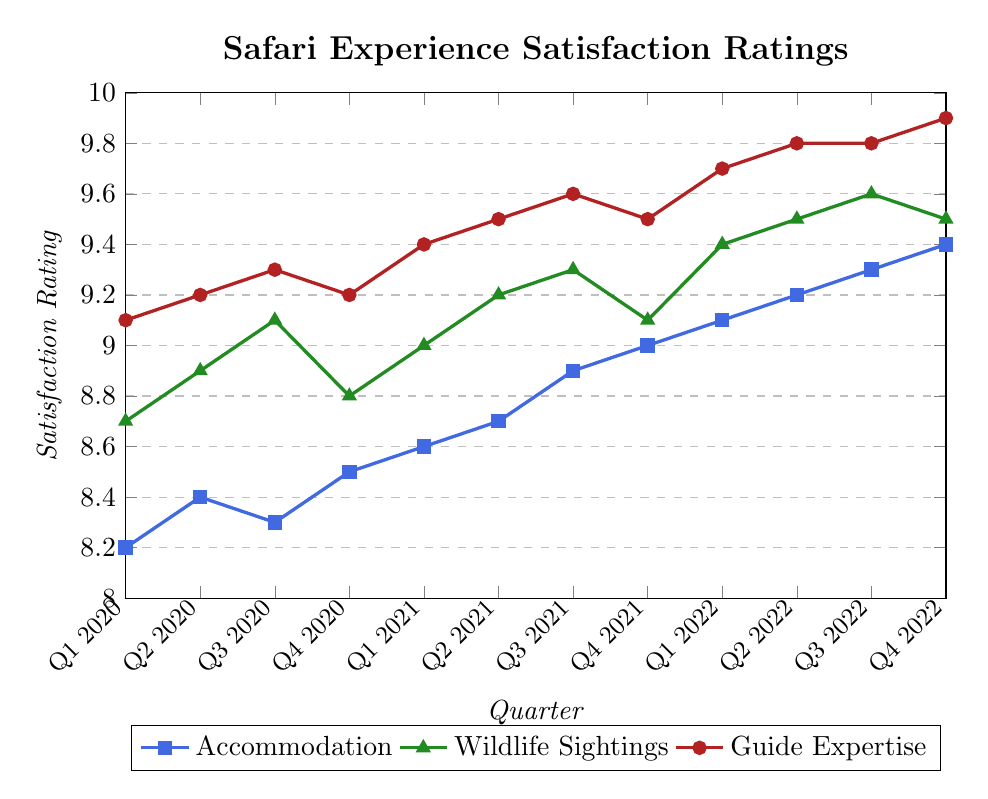What is the highest satisfaction rating for Guide Expertise and when did it occur? To determine the highest satisfaction rating for Guide Expertise, look at the red line representing Guide Expertise and find the peak value. This occurs at Q4 2022 with a value of 9.9.
Answer: 9.9, Q4 2022 Between Q1 2020 and Q4 2022, which aspect shows the most significant increase in satisfaction? Calculate the differences between Q1 2020 and Q4 2022 for each aspect. Accommodation increased from 8.2 to 9.4 by 1.2, Wildlife Sightings increased from 8.7 to 9.5 by 0.8, and Guide Expertise increased from 9.1 to 9.9 by 0.8. The highest increase is in Accommodation with a difference of 1.2.
Answer: Accommodation From Q3 2020 to Q4 2020, what was the trend for Wildlife Sightings? Notice the green line representing Wildlife Sightings. From Q3 2020 to Q4 2020, the line drops from 9.1 to 8.8, showing a downward trend.
Answer: Downward What is the average satisfaction rating for Accommodation across the entire period? Sum the values for Accommodation across all quarters and divide by the number of quarters. The sum is 8.2+8.4+8.3+8.5+8.6+8.7+8.9+9.0+9.1+9.2+9.3+9.4 = 105.6. There are 12 quarters, so the average is 105.6/12 = 8.8.
Answer: 8.8 Which quarter had the lowest satisfaction rating for any aspect, and what was the value? Identify the lowest ratings for each aspect: Accommodation is 8.2 (Q1 2020), Wildlife Sightings is 8.8 (Q4 2020), and Guide Expertise is 9.1 (Q1 2020 and Q4 2020). The lowest rating overall is Accommodation in Q1 2020 with 8.2.
Answer: Q1 2020, 8.2 How does the satisfaction rating for Guide Expertise in Q4 2022 compare to Q4 2021? For Guide Expertise, compare the value in Q4 2021 (9.5) to Q4 2022 (9.9). The rating is higher in Q4 2022 by 0.4.
Answer: Higher by 0.4 Which quarter shows the highest satisfaction rating for Wildlife Sightings, and what is the value? Look at the green line representing Wildlife Sightings to find the peak value in Q3 2022, which is 9.6.
Answer: Q3 2022, 9.6 